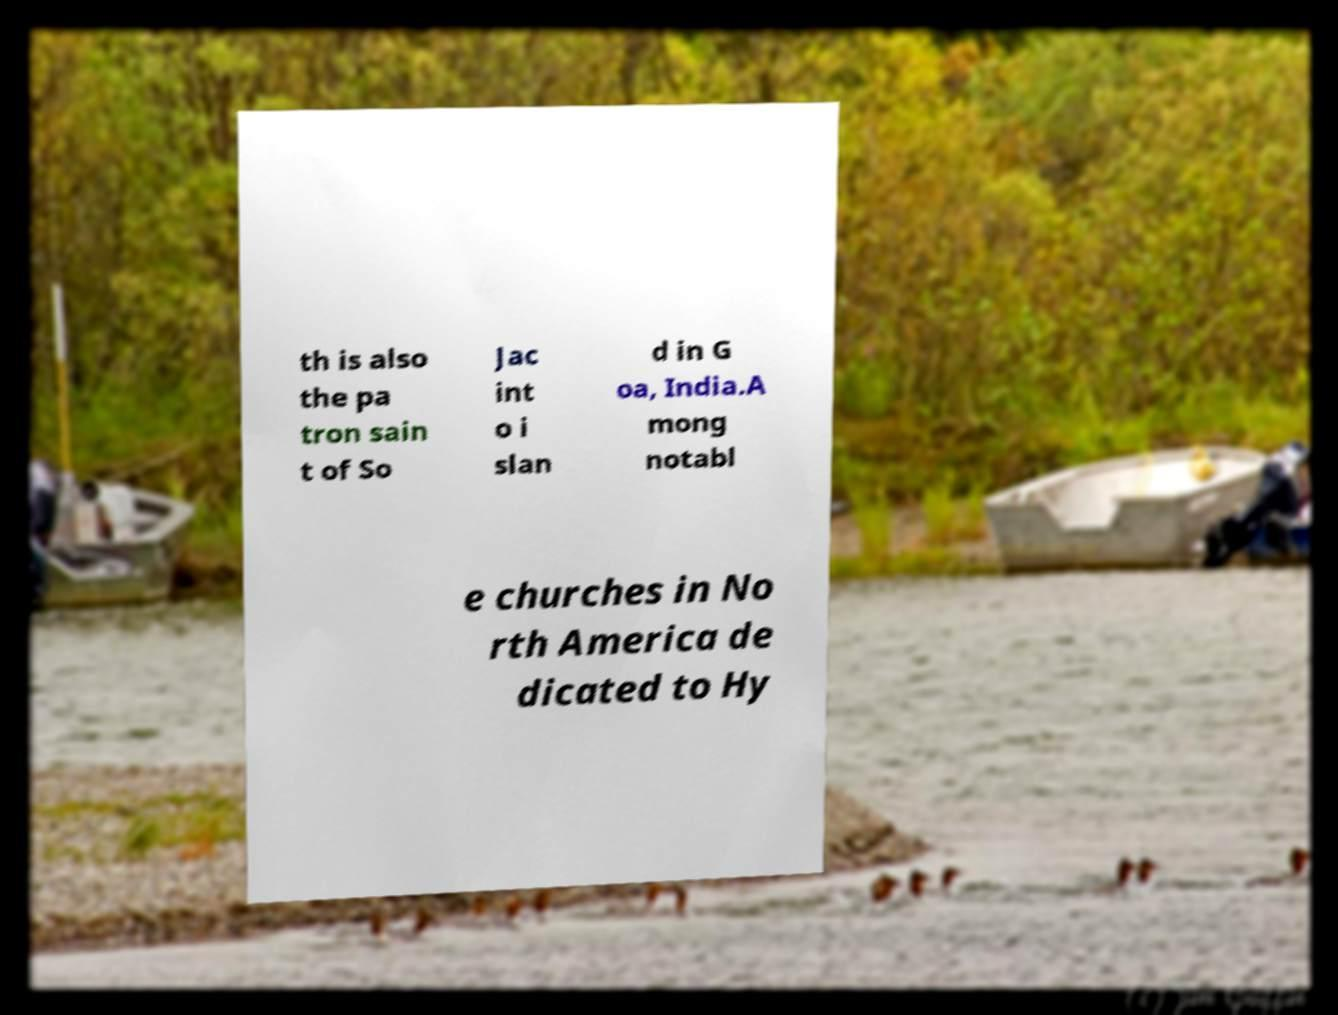Could you assist in decoding the text presented in this image and type it out clearly? th is also the pa tron sain t of So Jac int o i slan d in G oa, India.A mong notabl e churches in No rth America de dicated to Hy 